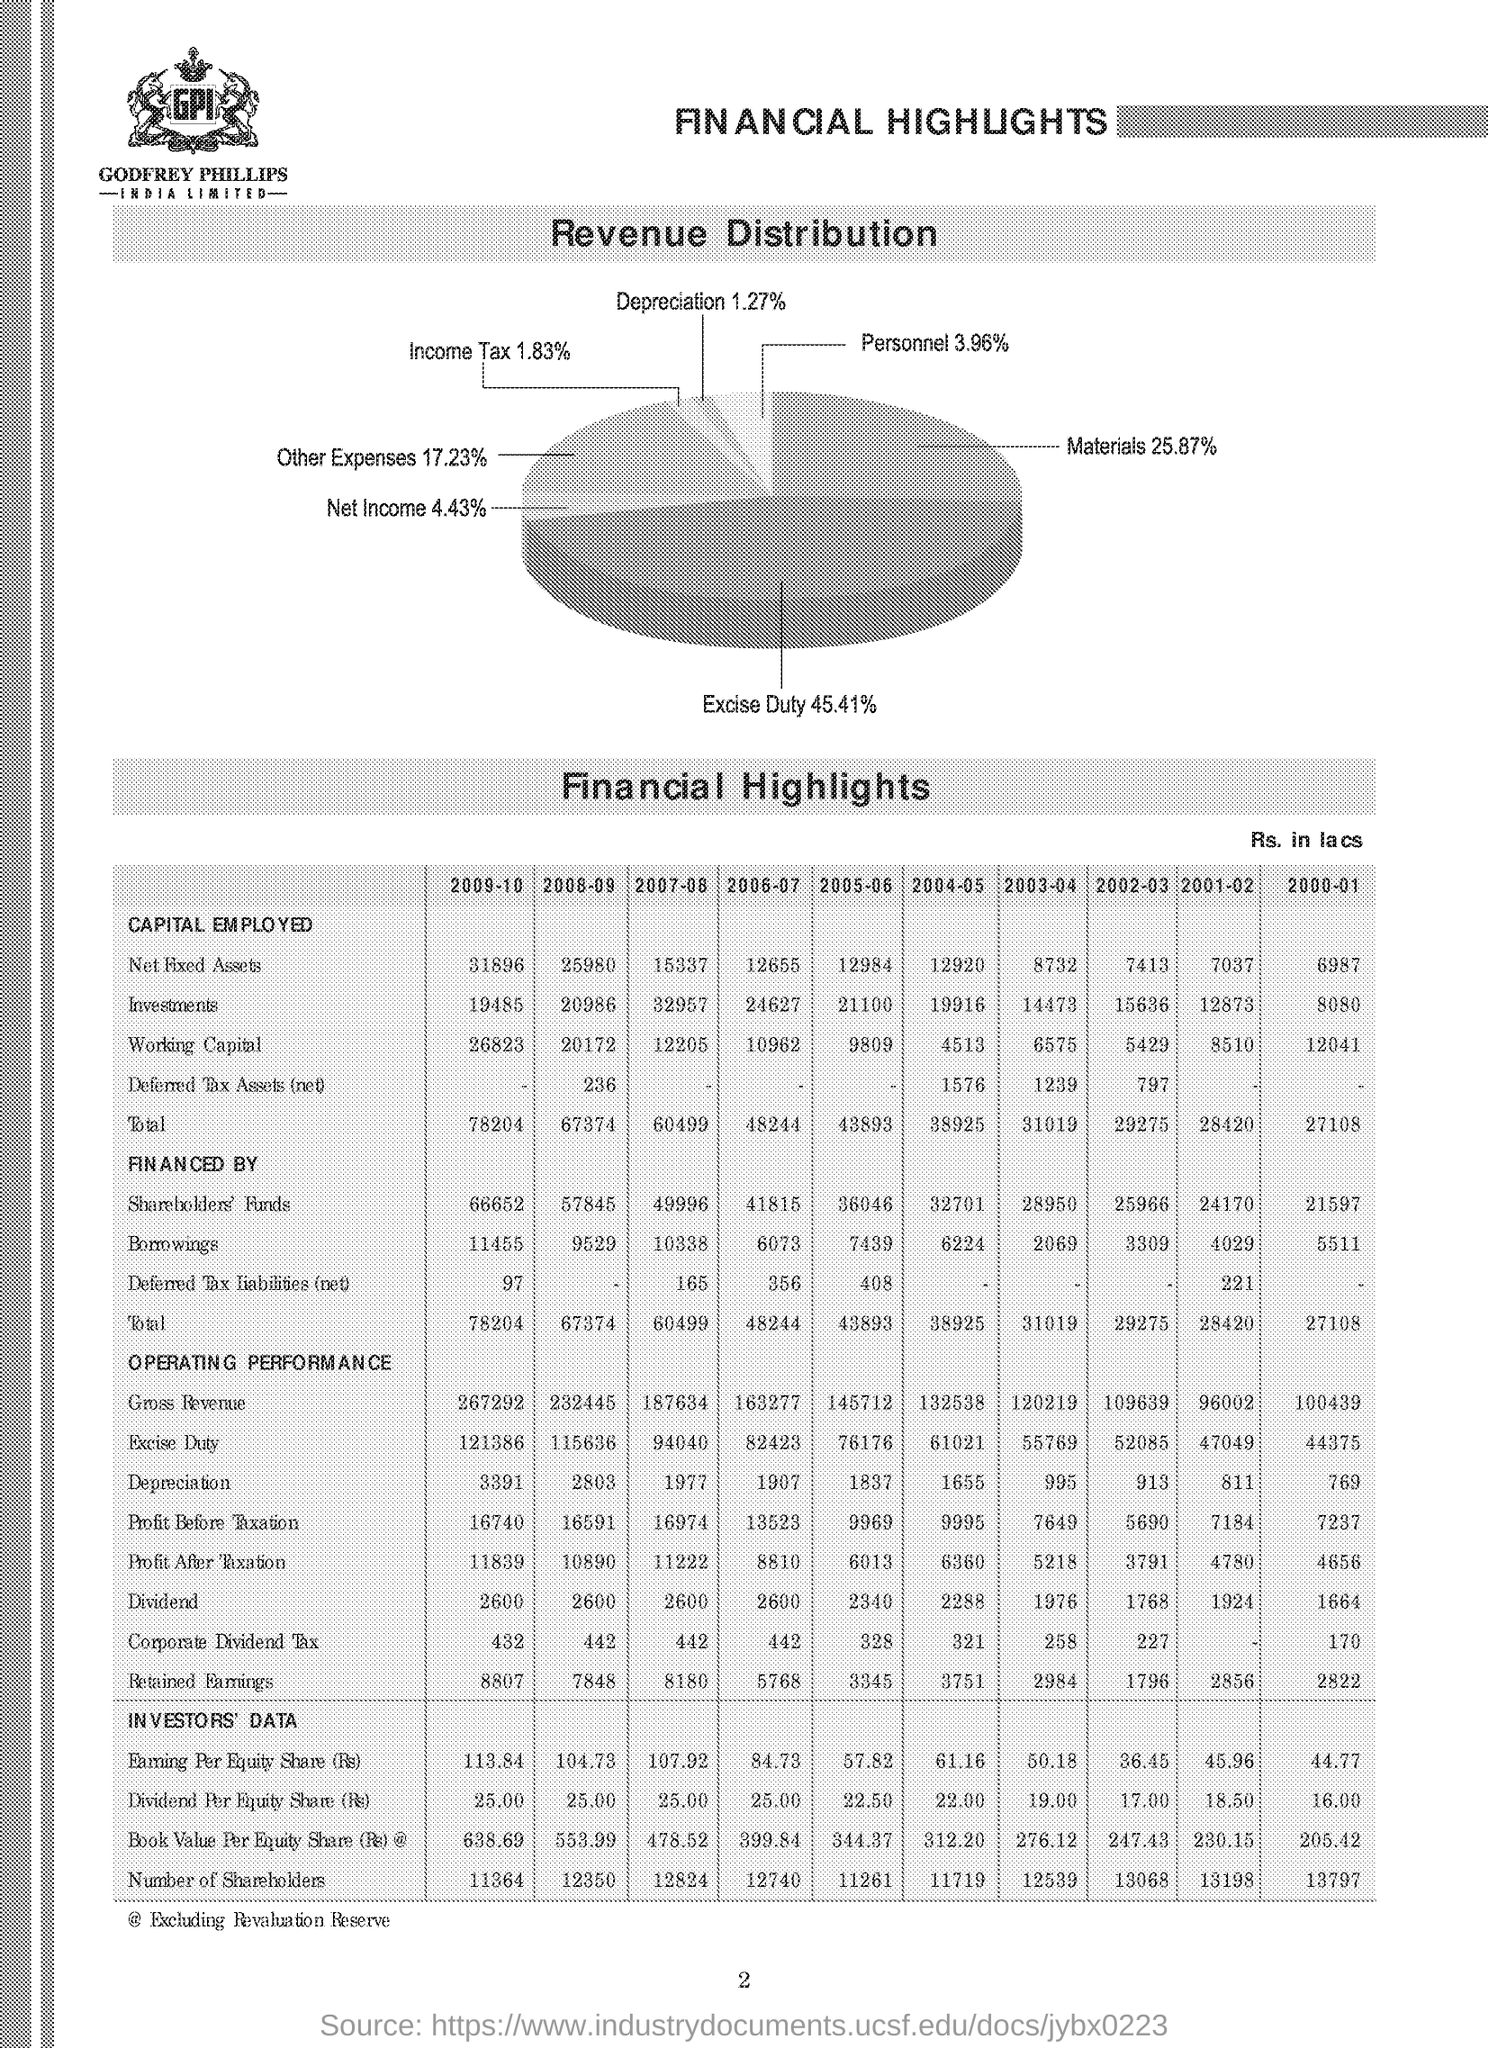Can you tell me which element is the highest in terms of percentage in revenue distribution? Excise Duty is the highest percentage in the revenue distribution, comprising 45.41% according to the pie chart. 